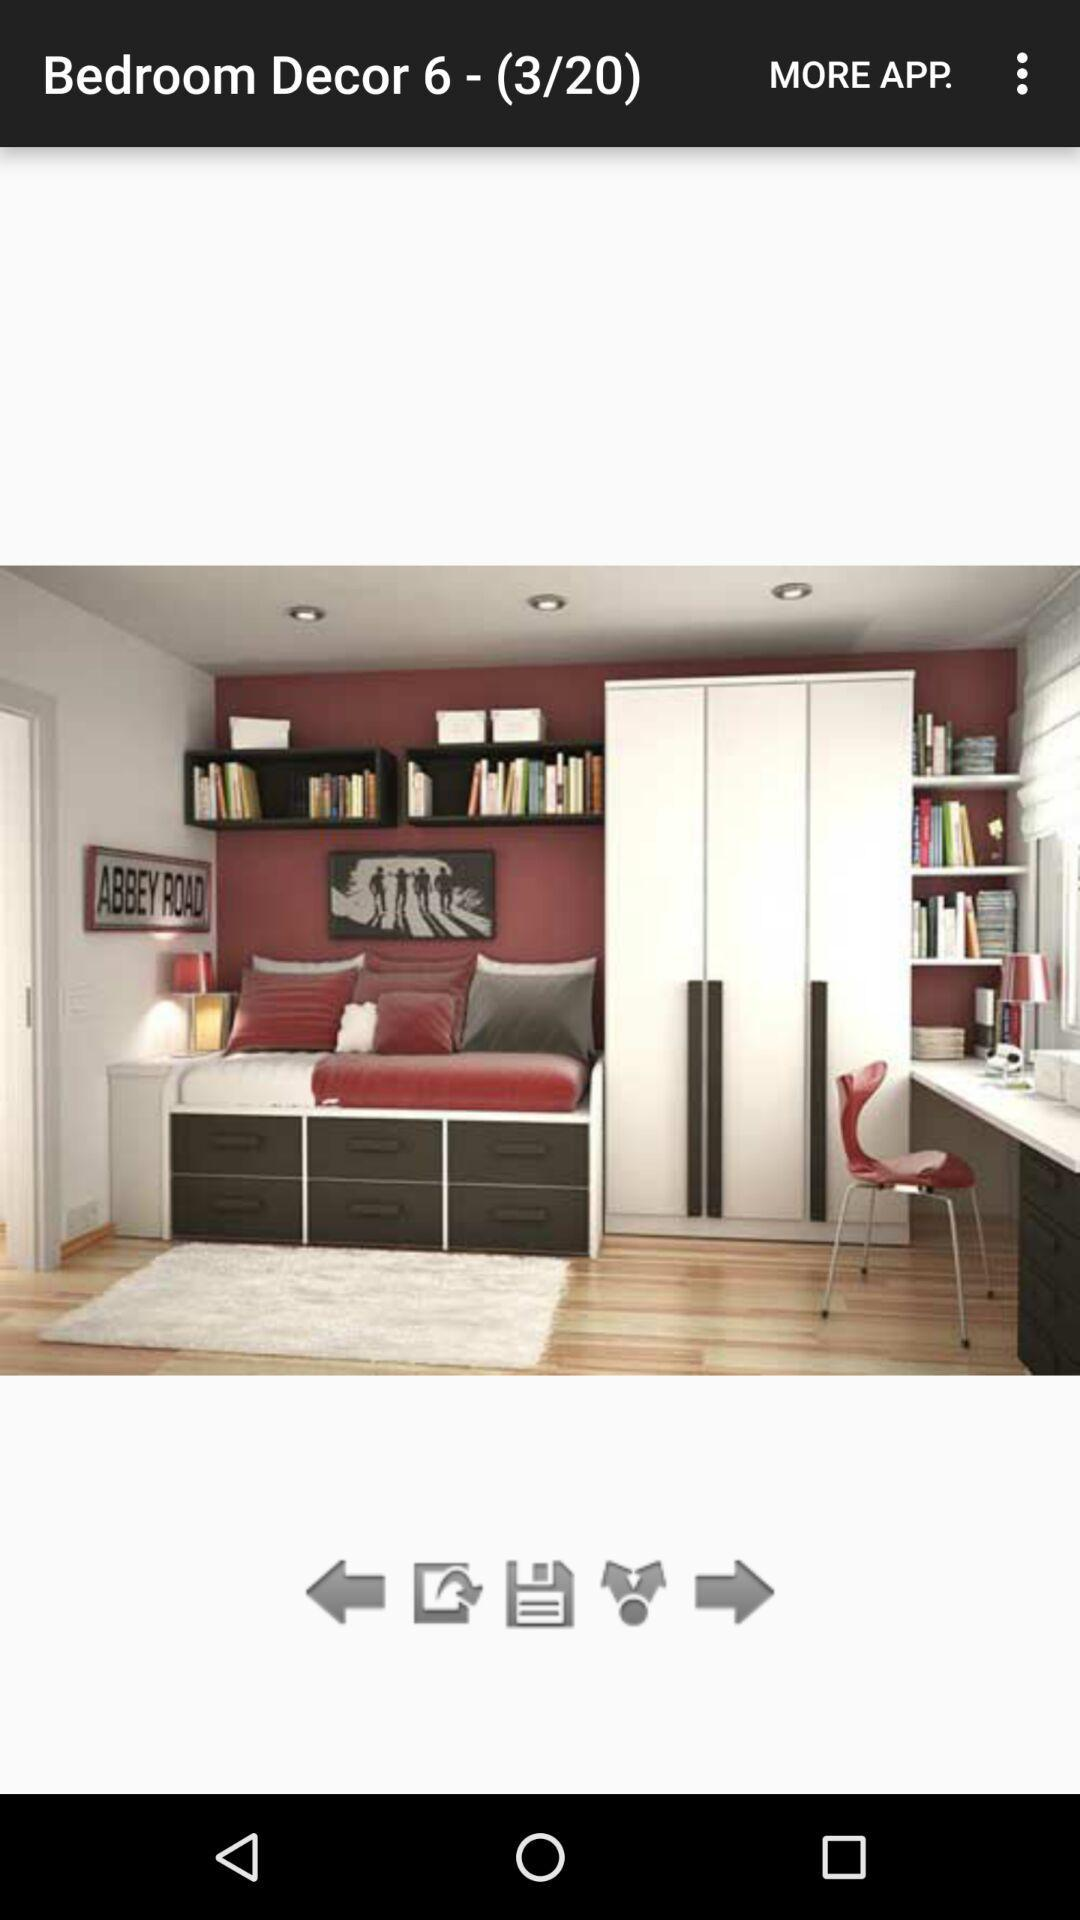On which image number am I? You are on image number 3. 